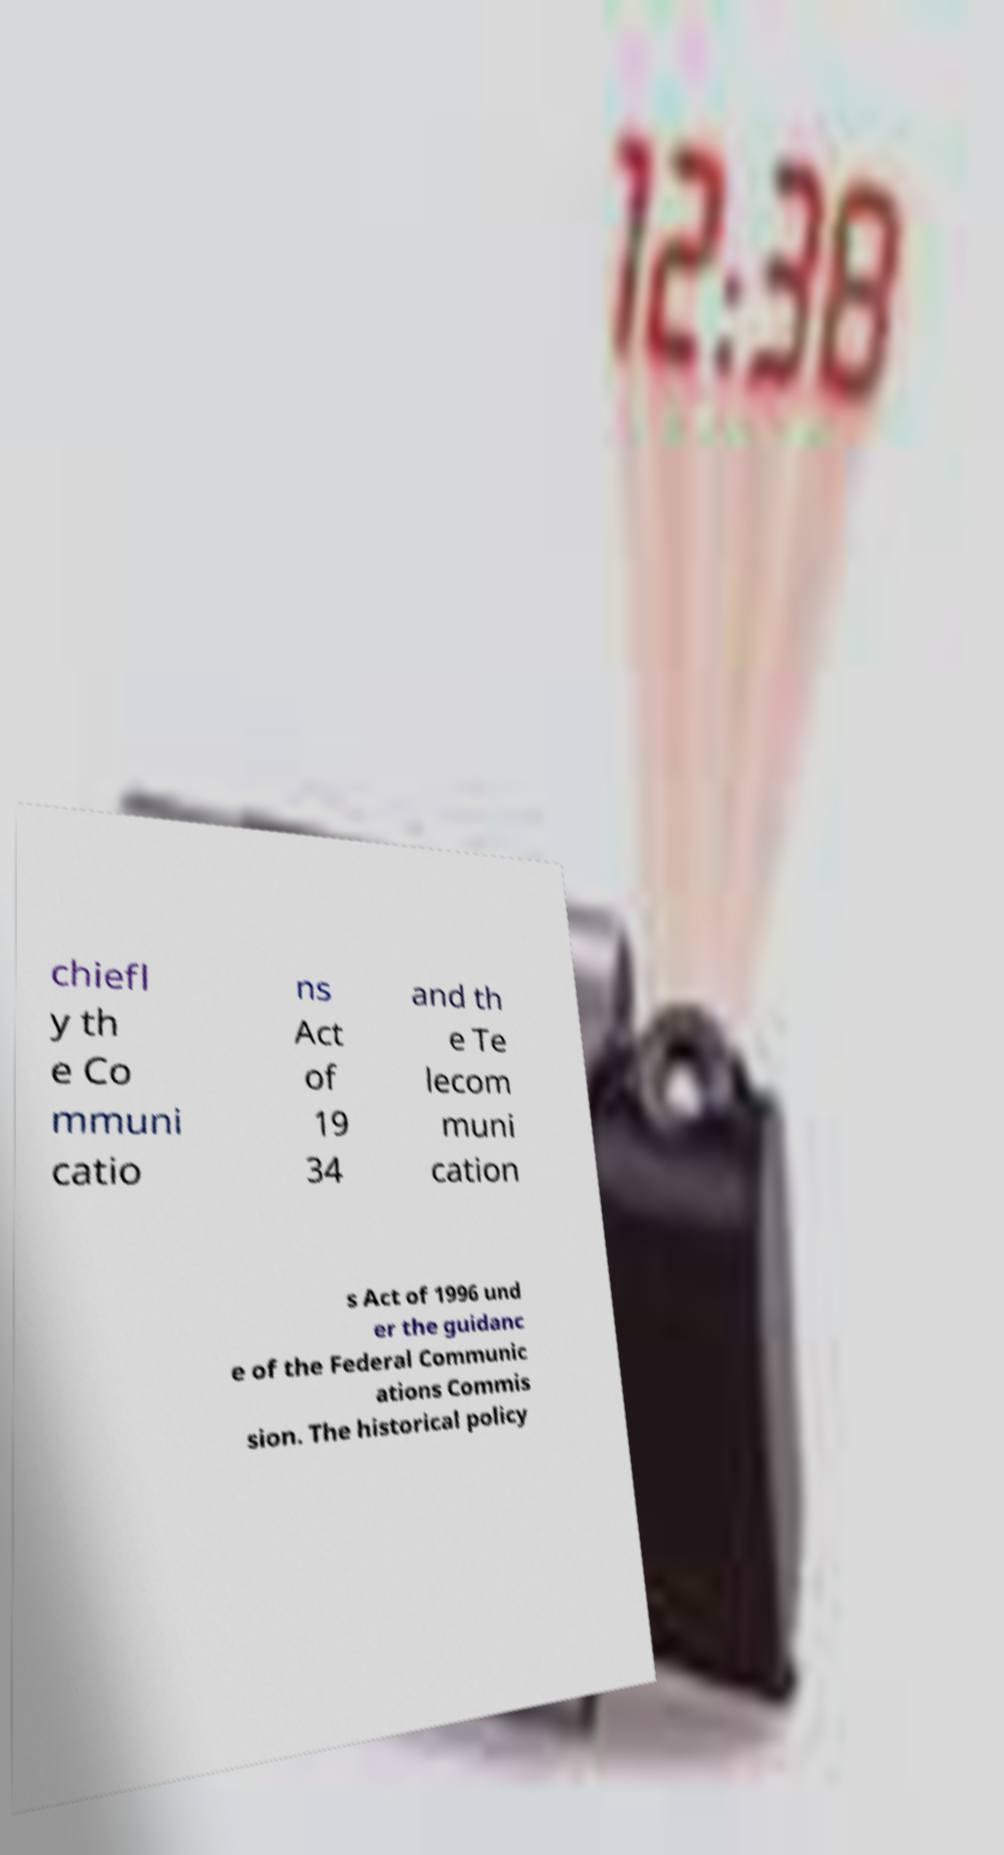Could you extract and type out the text from this image? chiefl y th e Co mmuni catio ns Act of 19 34 and th e Te lecom muni cation s Act of 1996 und er the guidanc e of the Federal Communic ations Commis sion. The historical policy 